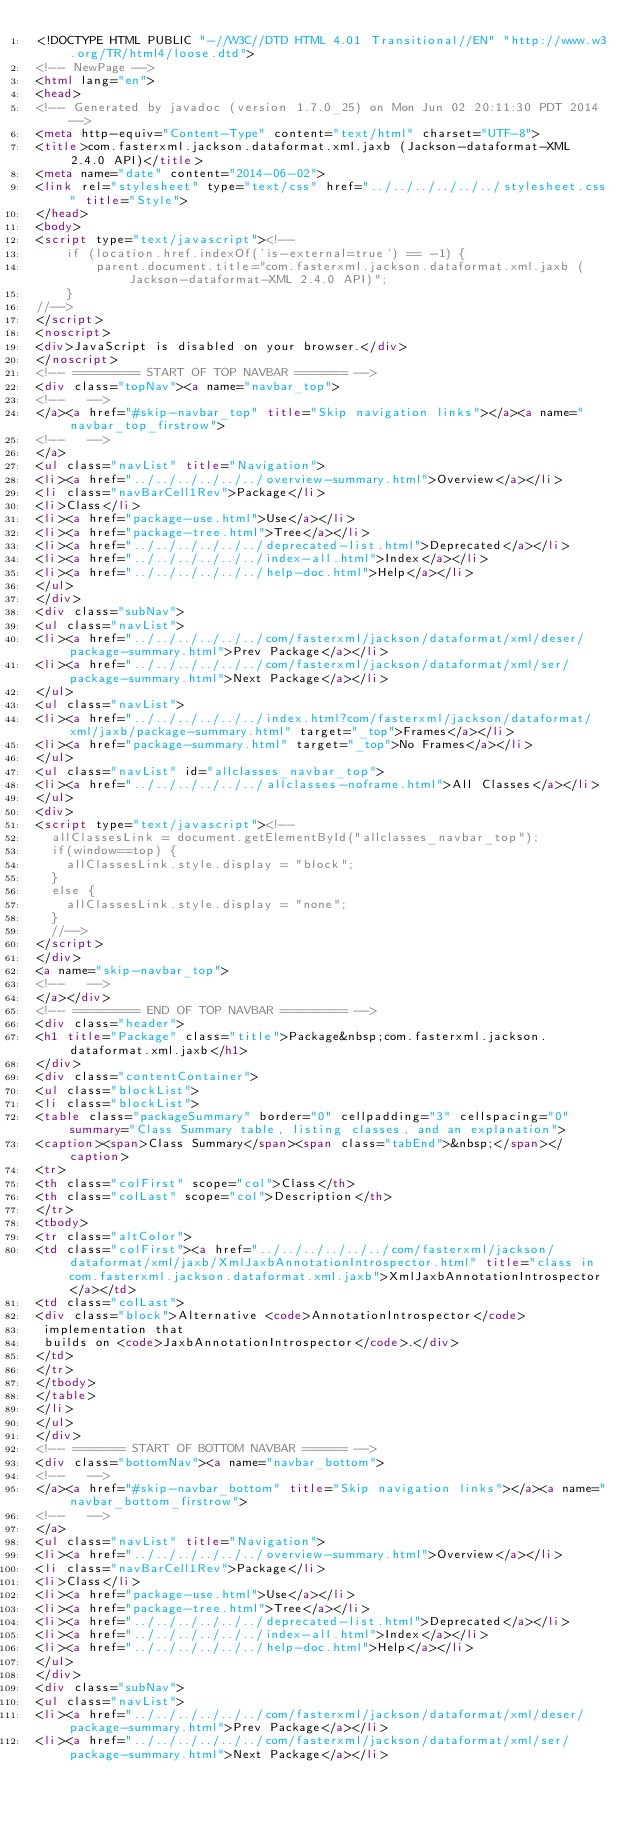<code> <loc_0><loc_0><loc_500><loc_500><_HTML_><!DOCTYPE HTML PUBLIC "-//W3C//DTD HTML 4.01 Transitional//EN" "http://www.w3.org/TR/html4/loose.dtd">
<!-- NewPage -->
<html lang="en">
<head>
<!-- Generated by javadoc (version 1.7.0_25) on Mon Jun 02 20:11:30 PDT 2014 -->
<meta http-equiv="Content-Type" content="text/html" charset="UTF-8">
<title>com.fasterxml.jackson.dataformat.xml.jaxb (Jackson-dataformat-XML 2.4.0 API)</title>
<meta name="date" content="2014-06-02">
<link rel="stylesheet" type="text/css" href="../../../../../../stylesheet.css" title="Style">
</head>
<body>
<script type="text/javascript"><!--
    if (location.href.indexOf('is-external=true') == -1) {
        parent.document.title="com.fasterxml.jackson.dataformat.xml.jaxb (Jackson-dataformat-XML 2.4.0 API)";
    }
//-->
</script>
<noscript>
<div>JavaScript is disabled on your browser.</div>
</noscript>
<!-- ========= START OF TOP NAVBAR ======= -->
<div class="topNav"><a name="navbar_top">
<!--   -->
</a><a href="#skip-navbar_top" title="Skip navigation links"></a><a name="navbar_top_firstrow">
<!--   -->
</a>
<ul class="navList" title="Navigation">
<li><a href="../../../../../../overview-summary.html">Overview</a></li>
<li class="navBarCell1Rev">Package</li>
<li>Class</li>
<li><a href="package-use.html">Use</a></li>
<li><a href="package-tree.html">Tree</a></li>
<li><a href="../../../../../../deprecated-list.html">Deprecated</a></li>
<li><a href="../../../../../../index-all.html">Index</a></li>
<li><a href="../../../../../../help-doc.html">Help</a></li>
</ul>
</div>
<div class="subNav">
<ul class="navList">
<li><a href="../../../../../../com/fasterxml/jackson/dataformat/xml/deser/package-summary.html">Prev Package</a></li>
<li><a href="../../../../../../com/fasterxml/jackson/dataformat/xml/ser/package-summary.html">Next Package</a></li>
</ul>
<ul class="navList">
<li><a href="../../../../../../index.html?com/fasterxml/jackson/dataformat/xml/jaxb/package-summary.html" target="_top">Frames</a></li>
<li><a href="package-summary.html" target="_top">No Frames</a></li>
</ul>
<ul class="navList" id="allclasses_navbar_top">
<li><a href="../../../../../../allclasses-noframe.html">All Classes</a></li>
</ul>
<div>
<script type="text/javascript"><!--
  allClassesLink = document.getElementById("allclasses_navbar_top");
  if(window==top) {
    allClassesLink.style.display = "block";
  }
  else {
    allClassesLink.style.display = "none";
  }
  //-->
</script>
</div>
<a name="skip-navbar_top">
<!--   -->
</a></div>
<!-- ========= END OF TOP NAVBAR ========= -->
<div class="header">
<h1 title="Package" class="title">Package&nbsp;com.fasterxml.jackson.dataformat.xml.jaxb</h1>
</div>
<div class="contentContainer">
<ul class="blockList">
<li class="blockList">
<table class="packageSummary" border="0" cellpadding="3" cellspacing="0" summary="Class Summary table, listing classes, and an explanation">
<caption><span>Class Summary</span><span class="tabEnd">&nbsp;</span></caption>
<tr>
<th class="colFirst" scope="col">Class</th>
<th class="colLast" scope="col">Description</th>
</tr>
<tbody>
<tr class="altColor">
<td class="colFirst"><a href="../../../../../../com/fasterxml/jackson/dataformat/xml/jaxb/XmlJaxbAnnotationIntrospector.html" title="class in com.fasterxml.jackson.dataformat.xml.jaxb">XmlJaxbAnnotationIntrospector</a></td>
<td class="colLast">
<div class="block">Alternative <code>AnnotationIntrospector</code>
 implementation that
 builds on <code>JaxbAnnotationIntrospector</code>.</div>
</td>
</tr>
</tbody>
</table>
</li>
</ul>
</div>
<!-- ======= START OF BOTTOM NAVBAR ====== -->
<div class="bottomNav"><a name="navbar_bottom">
<!--   -->
</a><a href="#skip-navbar_bottom" title="Skip navigation links"></a><a name="navbar_bottom_firstrow">
<!--   -->
</a>
<ul class="navList" title="Navigation">
<li><a href="../../../../../../overview-summary.html">Overview</a></li>
<li class="navBarCell1Rev">Package</li>
<li>Class</li>
<li><a href="package-use.html">Use</a></li>
<li><a href="package-tree.html">Tree</a></li>
<li><a href="../../../../../../deprecated-list.html">Deprecated</a></li>
<li><a href="../../../../../../index-all.html">Index</a></li>
<li><a href="../../../../../../help-doc.html">Help</a></li>
</ul>
</div>
<div class="subNav">
<ul class="navList">
<li><a href="../../../../../../com/fasterxml/jackson/dataformat/xml/deser/package-summary.html">Prev Package</a></li>
<li><a href="../../../../../../com/fasterxml/jackson/dataformat/xml/ser/package-summary.html">Next Package</a></li></code> 